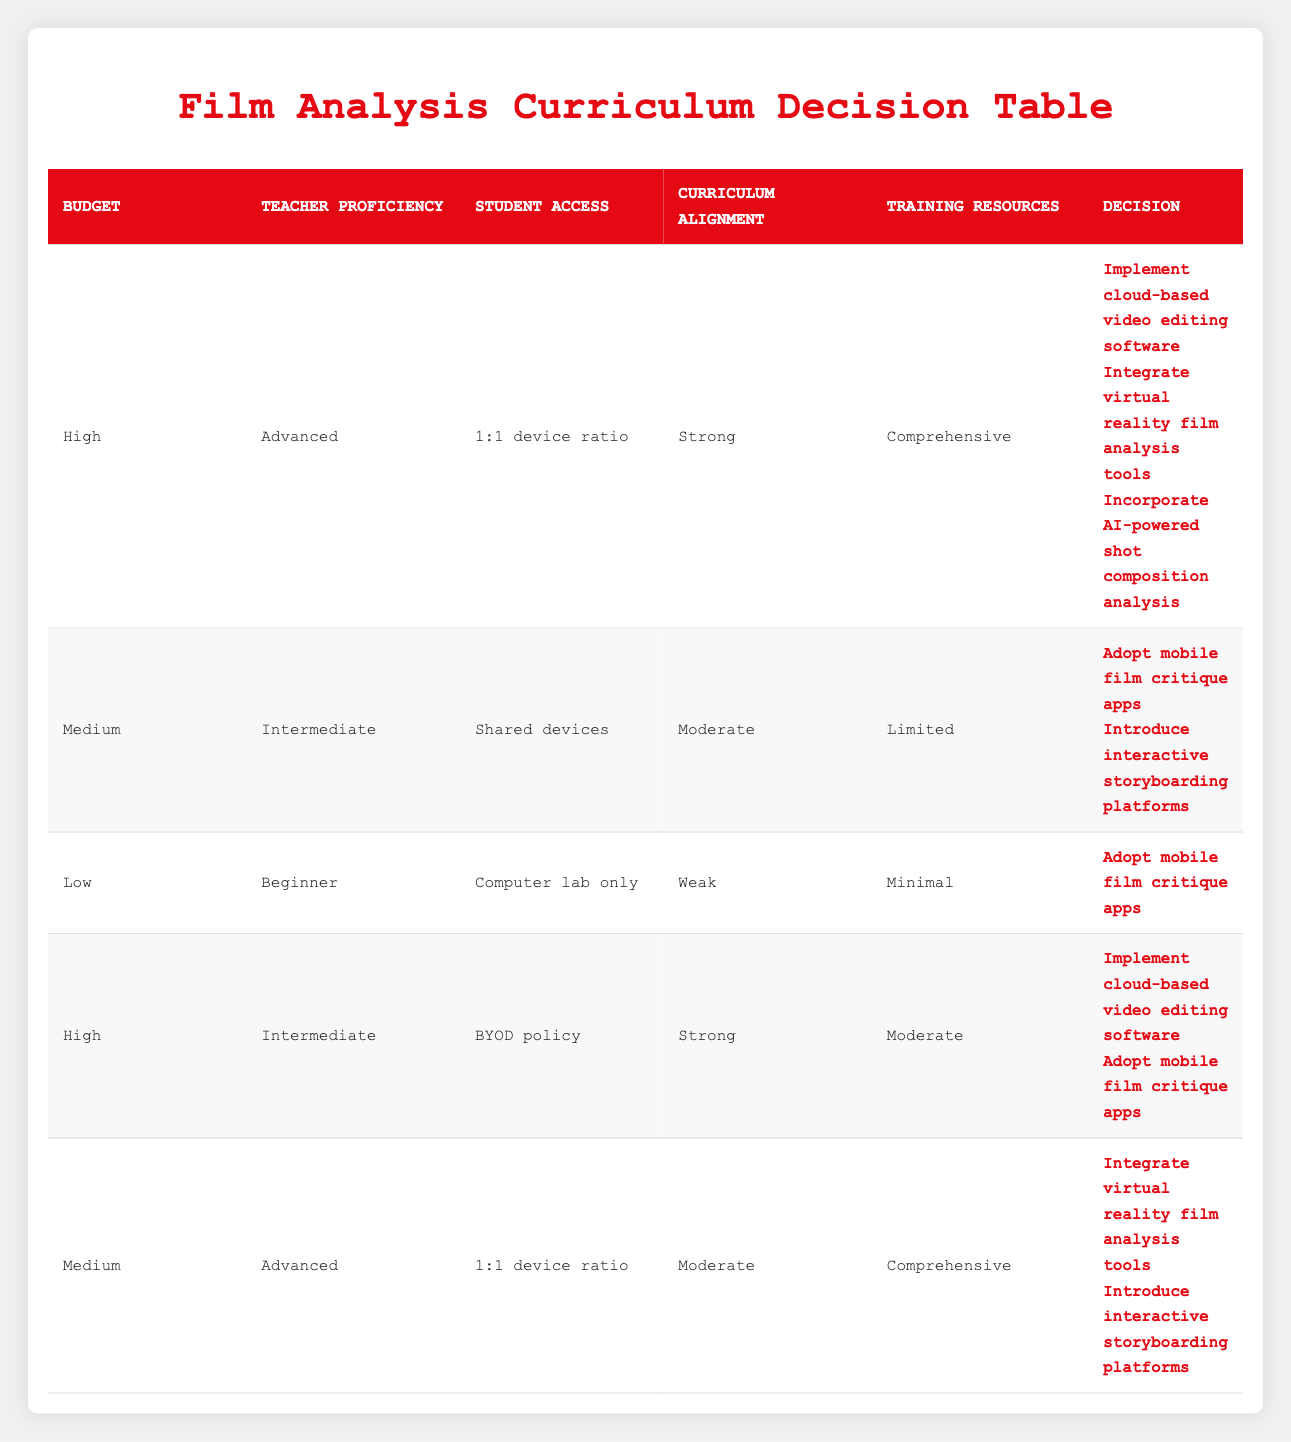What actions can be implemented when the budget is high and teacher proficiency is advanced? From the table, if the budget is high and teacher proficiency is advanced, the decisions include implementing cloud-based video editing software, integrating virtual reality film analysis tools, and incorporating AI-powered shot composition analysis.
Answer: Implement cloud-based video editing software, integrate virtual reality film analysis tools, incorporate AI-powered shot composition analysis Is there a decision option available for low budget with minimal training resources? Looking at the table, the rule for low budget and minimal training resources shows that the only decision available is to adopt mobile film critique apps.
Answer: Yes, adopt mobile film critique apps What is the average student access type across all decision rules? The available types for student access are: 1:1 device ratio, shared devices, computer lab only, BYOD policy. Counting these types: 2 for 1:1 device ratio, 2 for shared devices, 1 for computer lab only, and 1 for BYOD. The average is (2 + 2 + 1 + 1) / 4 = 1.5, indicating there's more representation for 1:1 and shared devices.
Answer: 1.5 Are there decisions available when access to devices is a shared setup? Yes, if student access is through shared devices, the decisions indicated are to adopt mobile film critique apps and introduce interactive storyboarding platforms.
Answer: Yes, adopt mobile film critique apps, introduce interactive storyboarding platforms Which decisions can be made if there is a medium budget but the teacher has advanced proficiency? According to the table, with a medium budget and advanced teacher proficiency, the decisions are to integrate virtual reality film analysis tools and introduce interactive storyboarding platforms.
Answer: Integrate virtual reality film analysis tools, introduce interactive storyboarding platforms What combinations lead to adopting mobile film critique apps? Reading through the table, the conditions leading to adopting mobile film critique apps occur with: low budget and minimal resources; medium budget with intermediate teaching proficiency and shared devices; and high budget with intermediate proficiency and BYOD policy.
Answer: Low budget, medium budget with limited resources, high budget with mixed proficiency 